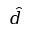<formula> <loc_0><loc_0><loc_500><loc_500>\hat { d }</formula> 